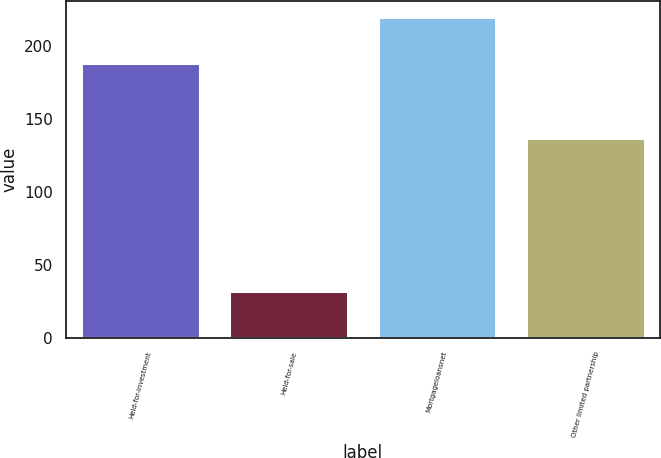Convert chart. <chart><loc_0><loc_0><loc_500><loc_500><bar_chart><fcel>Held-for-investment<fcel>Held-for-sale<fcel>Mortgageloansnet<fcel>Other limited partnership<nl><fcel>188<fcel>32<fcel>220<fcel>137<nl></chart> 